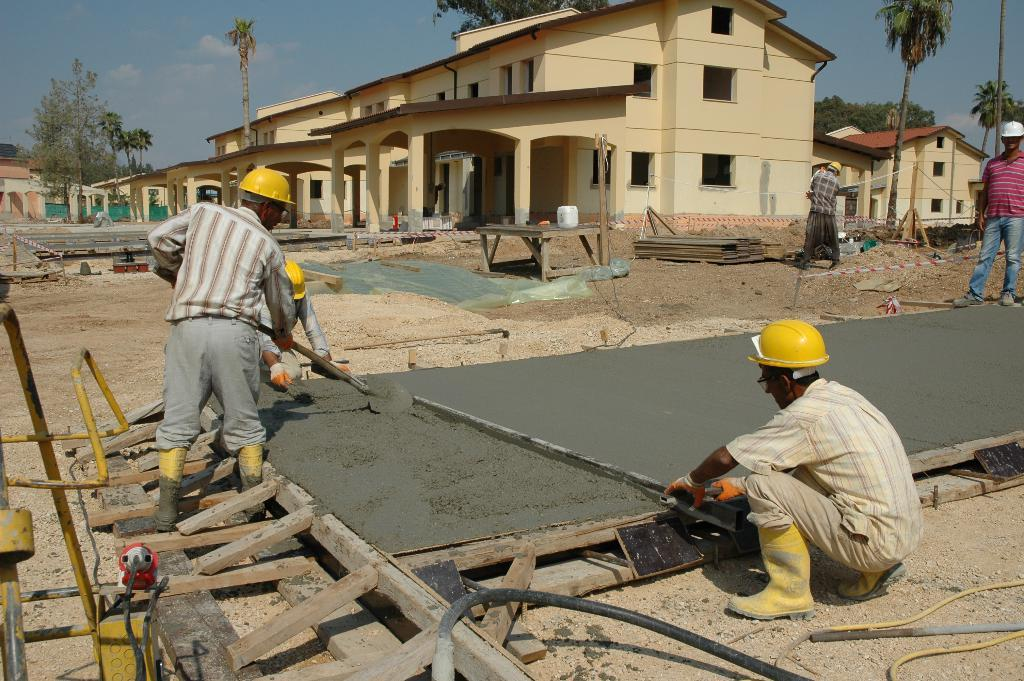What activity are the persons in the image engaged in? The persons in the image are doing construction work. What object can be seen in the image that is commonly used for holding or displaying items? There is a table in the image. What material is used to make the objects visible in the image? There are wooden sticks in the image. What type of structures can be seen in the background of the image? There are houses in the background of the image. What type of natural vegetation is visible in the background of the image? There are trees in the background of the image. What part of the natural environment is visible in the background of the image? The sky is visible in the background of the image. How many roses are on the calendar in the image? There is no calendar or rose present in the image. What type of facial expression can be seen on the face of the person in the image? There is no person's face visible in the image; only their bodies are shown while doing construction work. 